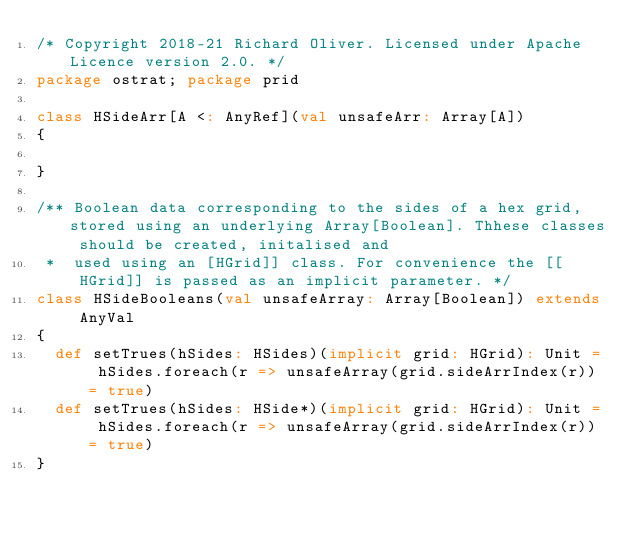<code> <loc_0><loc_0><loc_500><loc_500><_Scala_>/* Copyright 2018-21 Richard Oliver. Licensed under Apache Licence version 2.0. */
package ostrat; package prid

class HSideArr[A <: AnyRef](val unsafeArr: Array[A])
{

}

/** Boolean data corresponding to the sides of a hex grid, stored using an underlying Array[Boolean]. Thhese classes should be created, initalised and
 *  used using an [HGrid]] class. For convenience the [[HGrid]] is passed as an implicit parameter. */
class HSideBooleans(val unsafeArray: Array[Boolean]) extends AnyVal
{
  def setTrues(hSides: HSides)(implicit grid: HGrid): Unit = hSides.foreach(r => unsafeArray(grid.sideArrIndex(r)) = true)
  def setTrues(hSides: HSide*)(implicit grid: HGrid): Unit = hSides.foreach(r => unsafeArray(grid.sideArrIndex(r)) = true)
}</code> 